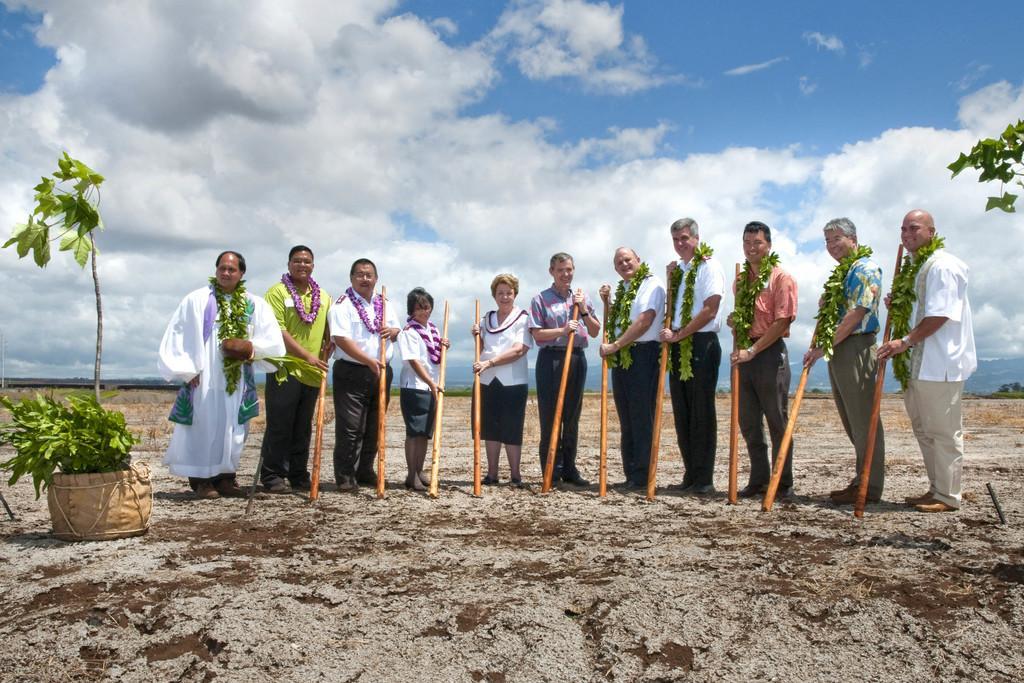How would you summarize this image in a sentence or two? In the image we can see there are many people standing, wearing clothes and holding a wooden stick in their hand. This is a soil, plant and a cloudy sky. This is a leaf garland. 